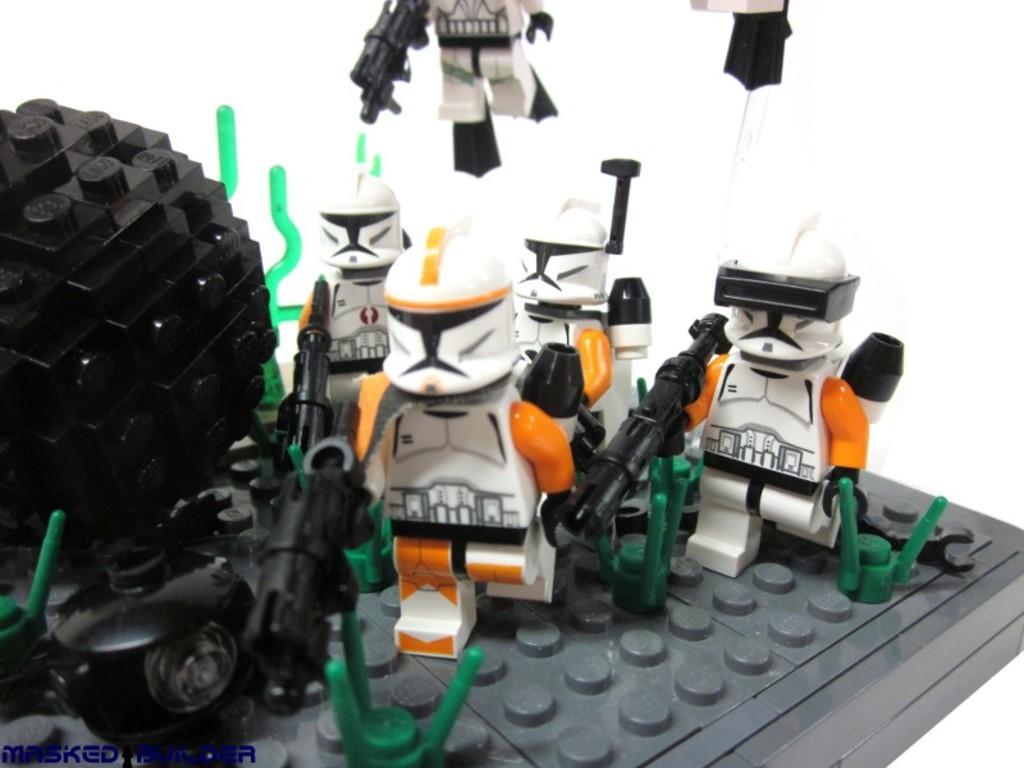How would you summarize this image in a sentence or two? In this image I can see few toys. They are in white,black and orange color. We can see black and green color object. They are on the grey color board. 